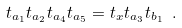Convert formula to latex. <formula><loc_0><loc_0><loc_500><loc_500>t _ { a _ { 1 } } t _ { a _ { 2 } } t _ { a _ { 4 } } t _ { a _ { 5 } } = t _ { x } t _ { a _ { 3 } } t _ { b _ { 1 } } \ .</formula> 